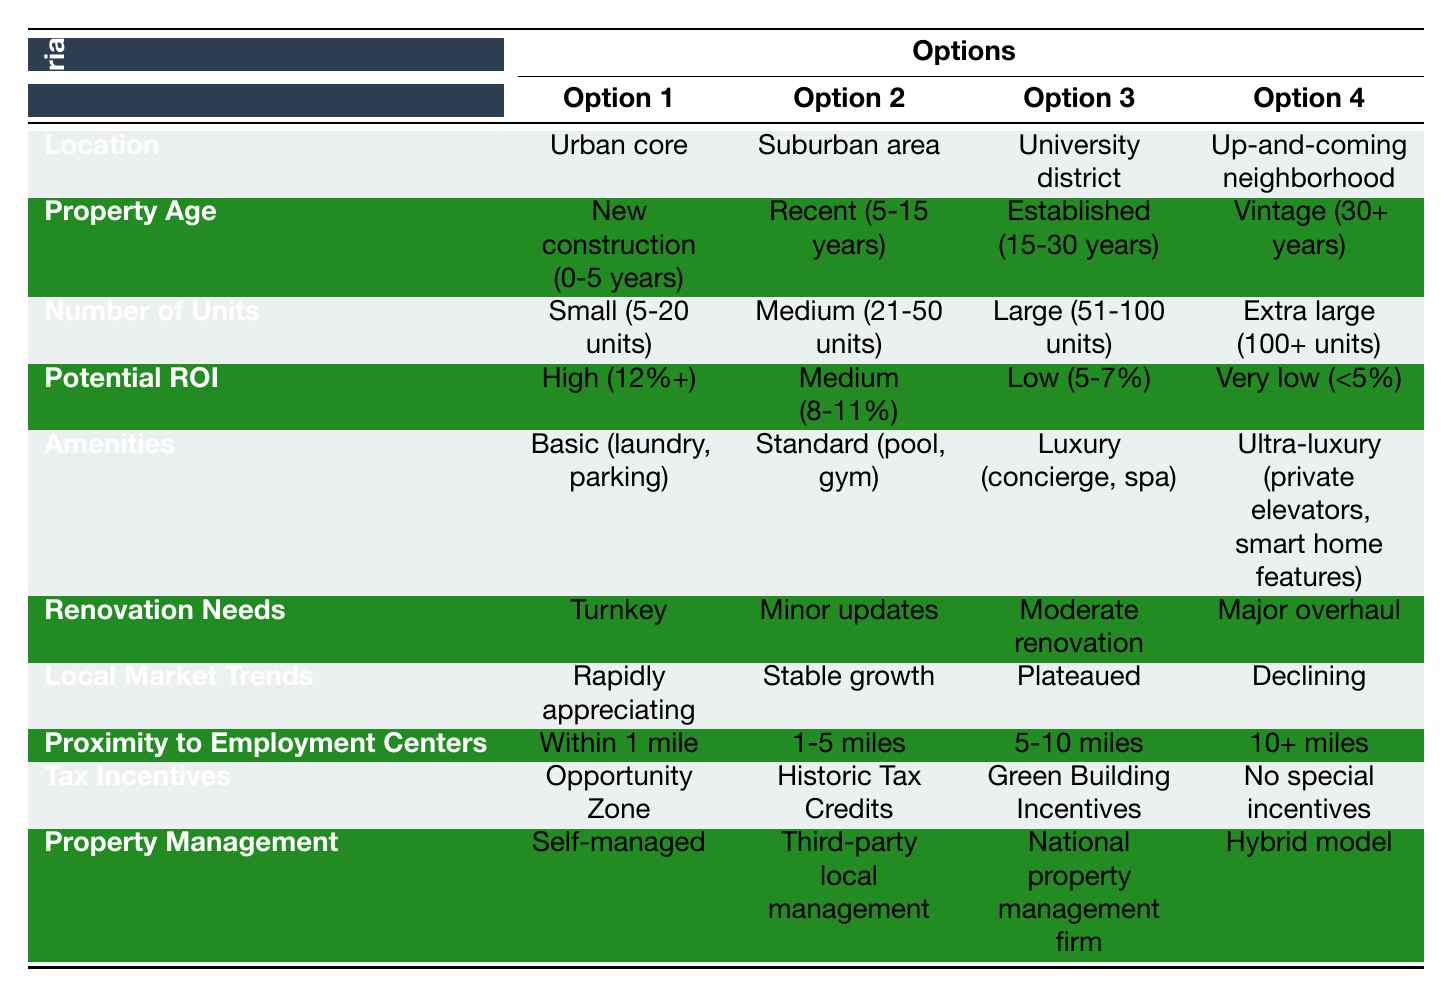What are the options for location? The table lists four options under the "Location" criterion: Urban core, Suburban area, University district, and Up-and-coming neighborhood.
Answer: Urban core, Suburban area, University district, Up-and-coming neighborhood How many options are listed for property age? There are four options for the "Property Age" criterion: New construction (0-5 years), Recent (5-15 years), Established (15-30 years), and Vintage (30+ years), so the count is four.
Answer: 4 Is there an option for "High" potential ROI? The "Potential ROI" criterion includes an option for "High (12%+)," meaning it is indeed available in the table.
Answer: Yes Which criterion has an option for "Ultra-luxury"? "Amenities" has an option for "Ultra-luxury (private elevators, smart home features)," indicating that this level of amenities is available.
Answer: Amenities What is the difference between the number of units in the "Small" and "Extra large" categories? "Small" is defined as 5-20 units, and "Extra large" is defined as 100+ units. Taking the maximum for "Extra large" as 100 and the minimum for "Small" as 5, the difference is 100 - 5 = 95 units.
Answer: 95 units If a property is labeled as "Turnkey" for renovation needs, what does that imply? "Turnkey" in renovation needs means that the property is ready to be occupied without needing any immediate work, suggesting it requires no additional renovation efforts.
Answer: Requires no immediate work Assuming you prioritize "Urban core" locations, which potential ROI options are available? With "Urban core" as a priority, you can choose any potential ROI option available: High (12%+), Medium (8-11%), Low (5-7%), or Very low (<5%). Thus, all options apply.
Answer: All options apply If a property's location is "Suburban area" and it is "Rapidly appreciating," what could this imply about the local market? "Suburban area" combined with "Rapidly appreciating" indicates that the property is in a region that not only has suburban characteristics but also exhibits an increase in property values, making it a potentially strong investment opportunity.
Answer: Strong investment opportunity Is there an option for "National property management firm"? Yes, under the "Property Management" criterion, there is an option labeled "National property management firm."
Answer: Yes 